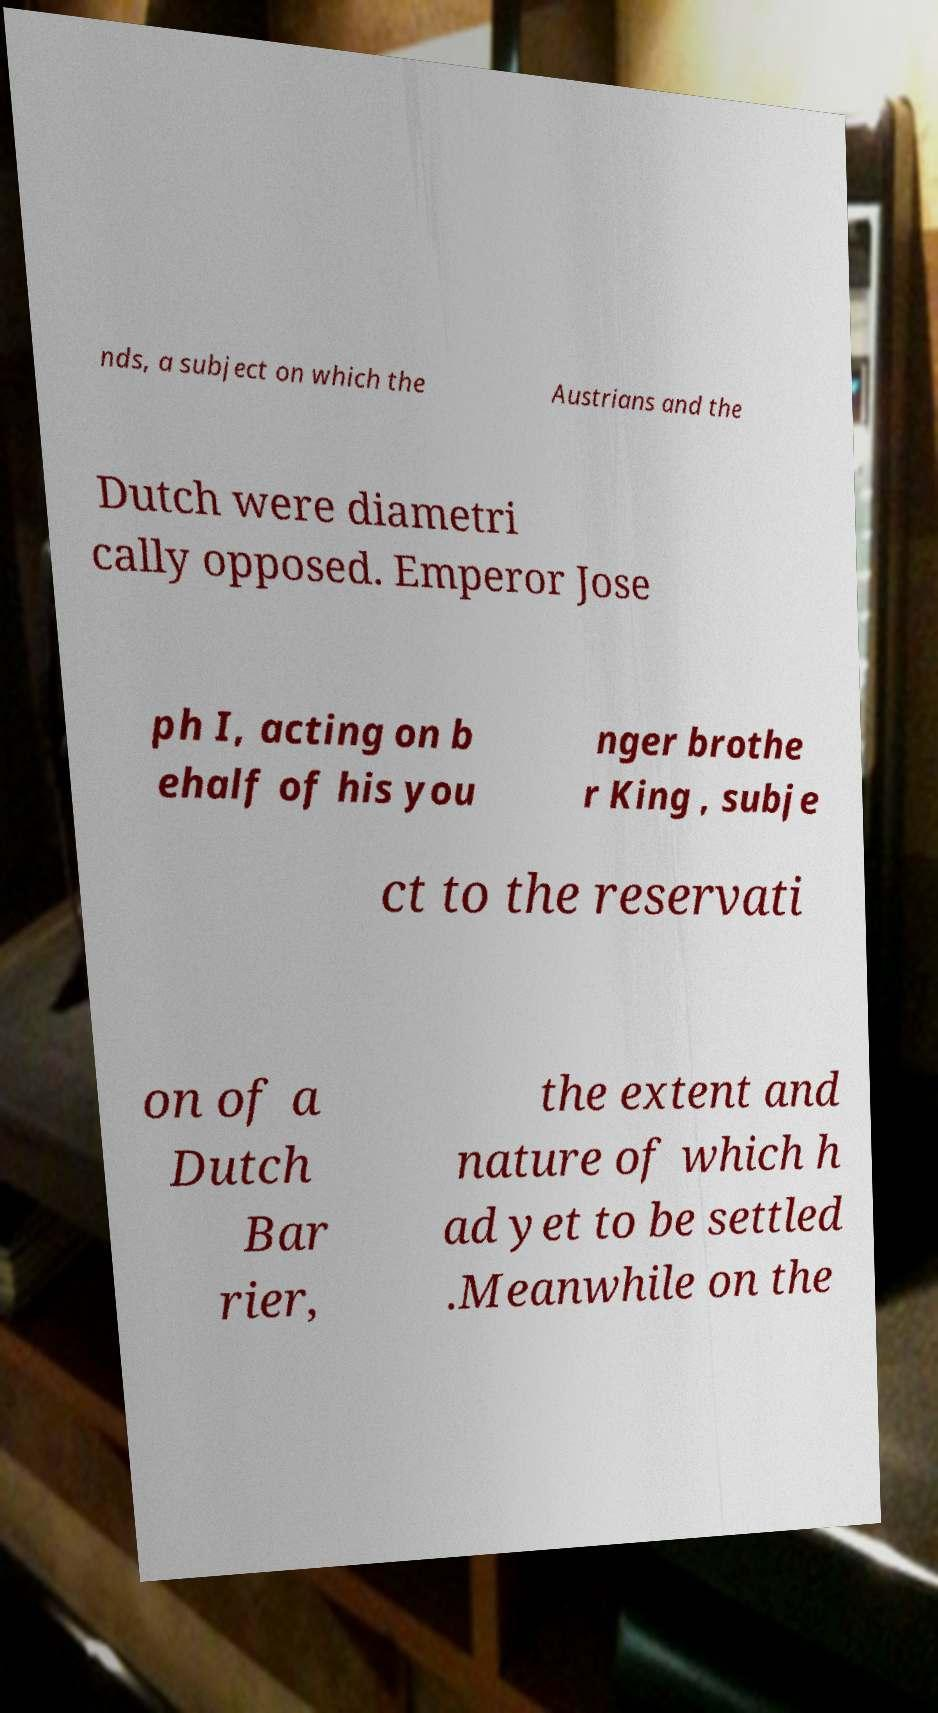Could you assist in decoding the text presented in this image and type it out clearly? nds, a subject on which the Austrians and the Dutch were diametri cally opposed. Emperor Jose ph I, acting on b ehalf of his you nger brothe r King , subje ct to the reservati on of a Dutch Bar rier, the extent and nature of which h ad yet to be settled .Meanwhile on the 